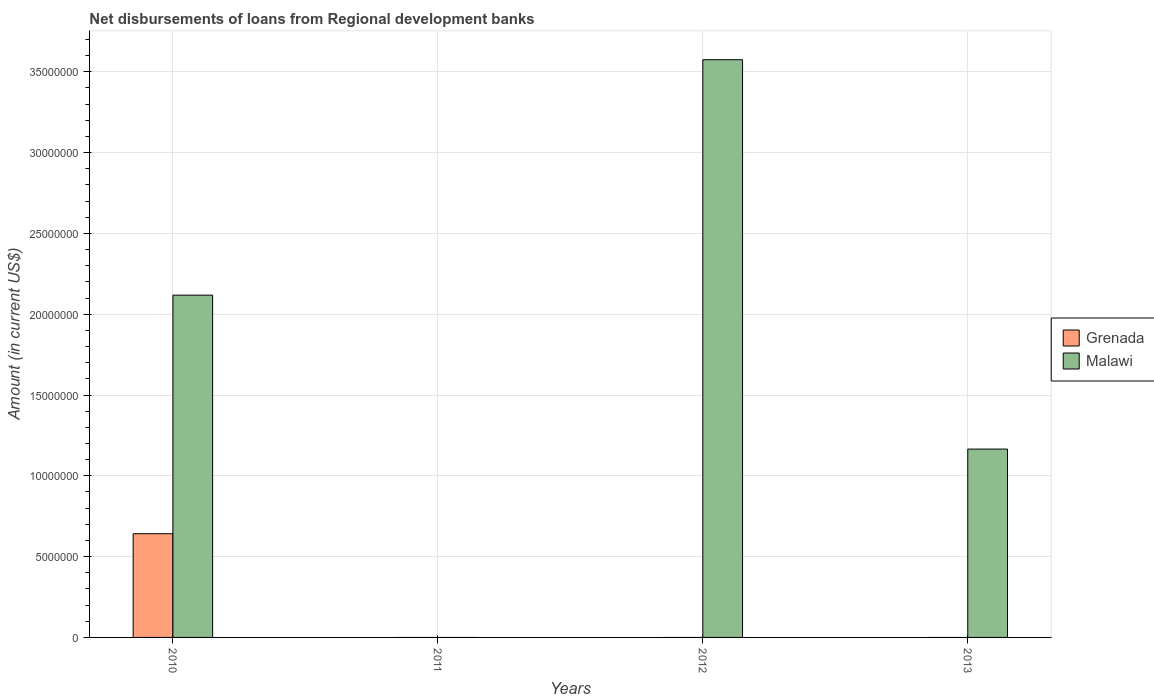Are the number of bars on each tick of the X-axis equal?
Offer a very short reply. No. How many bars are there on the 1st tick from the left?
Your answer should be very brief. 2. How many bars are there on the 1st tick from the right?
Keep it short and to the point. 1. What is the amount of disbursements of loans from regional development banks in Grenada in 2010?
Your answer should be compact. 6.42e+06. Across all years, what is the maximum amount of disbursements of loans from regional development banks in Malawi?
Your answer should be compact. 3.57e+07. What is the total amount of disbursements of loans from regional development banks in Malawi in the graph?
Give a very brief answer. 6.86e+07. What is the difference between the amount of disbursements of loans from regional development banks in Malawi in 2010 and that in 2012?
Provide a succinct answer. -1.46e+07. What is the difference between the amount of disbursements of loans from regional development banks in Malawi in 2012 and the amount of disbursements of loans from regional development banks in Grenada in 2013?
Your response must be concise. 3.57e+07. What is the average amount of disbursements of loans from regional development banks in Grenada per year?
Provide a succinct answer. 1.60e+06. In the year 2010, what is the difference between the amount of disbursements of loans from regional development banks in Grenada and amount of disbursements of loans from regional development banks in Malawi?
Your response must be concise. -1.48e+07. Is the amount of disbursements of loans from regional development banks in Malawi in 2010 less than that in 2013?
Keep it short and to the point. No. What is the difference between the highest and the lowest amount of disbursements of loans from regional development banks in Grenada?
Make the answer very short. 6.42e+06. In how many years, is the amount of disbursements of loans from regional development banks in Grenada greater than the average amount of disbursements of loans from regional development banks in Grenada taken over all years?
Offer a very short reply. 1. Are all the bars in the graph horizontal?
Your response must be concise. No. Does the graph contain grids?
Make the answer very short. Yes. What is the title of the graph?
Provide a short and direct response. Net disbursements of loans from Regional development banks. What is the label or title of the X-axis?
Your answer should be compact. Years. What is the label or title of the Y-axis?
Keep it short and to the point. Amount (in current US$). What is the Amount (in current US$) in Grenada in 2010?
Ensure brevity in your answer.  6.42e+06. What is the Amount (in current US$) in Malawi in 2010?
Your response must be concise. 2.12e+07. What is the Amount (in current US$) in Grenada in 2011?
Your answer should be compact. 0. What is the Amount (in current US$) of Grenada in 2012?
Give a very brief answer. 0. What is the Amount (in current US$) in Malawi in 2012?
Offer a very short reply. 3.57e+07. What is the Amount (in current US$) in Grenada in 2013?
Offer a very short reply. 0. What is the Amount (in current US$) in Malawi in 2013?
Offer a very short reply. 1.17e+07. Across all years, what is the maximum Amount (in current US$) in Grenada?
Ensure brevity in your answer.  6.42e+06. Across all years, what is the maximum Amount (in current US$) of Malawi?
Offer a very short reply. 3.57e+07. Across all years, what is the minimum Amount (in current US$) of Malawi?
Offer a very short reply. 0. What is the total Amount (in current US$) of Grenada in the graph?
Provide a succinct answer. 6.42e+06. What is the total Amount (in current US$) in Malawi in the graph?
Ensure brevity in your answer.  6.86e+07. What is the difference between the Amount (in current US$) in Malawi in 2010 and that in 2012?
Keep it short and to the point. -1.46e+07. What is the difference between the Amount (in current US$) of Malawi in 2010 and that in 2013?
Give a very brief answer. 9.53e+06. What is the difference between the Amount (in current US$) in Malawi in 2012 and that in 2013?
Offer a very short reply. 2.41e+07. What is the difference between the Amount (in current US$) of Grenada in 2010 and the Amount (in current US$) of Malawi in 2012?
Keep it short and to the point. -2.93e+07. What is the difference between the Amount (in current US$) of Grenada in 2010 and the Amount (in current US$) of Malawi in 2013?
Your answer should be very brief. -5.24e+06. What is the average Amount (in current US$) of Grenada per year?
Provide a short and direct response. 1.60e+06. What is the average Amount (in current US$) of Malawi per year?
Ensure brevity in your answer.  1.71e+07. In the year 2010, what is the difference between the Amount (in current US$) in Grenada and Amount (in current US$) in Malawi?
Provide a succinct answer. -1.48e+07. What is the ratio of the Amount (in current US$) in Malawi in 2010 to that in 2012?
Provide a succinct answer. 0.59. What is the ratio of the Amount (in current US$) in Malawi in 2010 to that in 2013?
Give a very brief answer. 1.82. What is the ratio of the Amount (in current US$) in Malawi in 2012 to that in 2013?
Make the answer very short. 3.07. What is the difference between the highest and the second highest Amount (in current US$) in Malawi?
Offer a very short reply. 1.46e+07. What is the difference between the highest and the lowest Amount (in current US$) in Grenada?
Offer a terse response. 6.42e+06. What is the difference between the highest and the lowest Amount (in current US$) of Malawi?
Offer a terse response. 3.57e+07. 